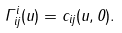Convert formula to latex. <formula><loc_0><loc_0><loc_500><loc_500>\Gamma ^ { i } _ { i j } ( u ) = c _ { i j } ( u , 0 ) .</formula> 